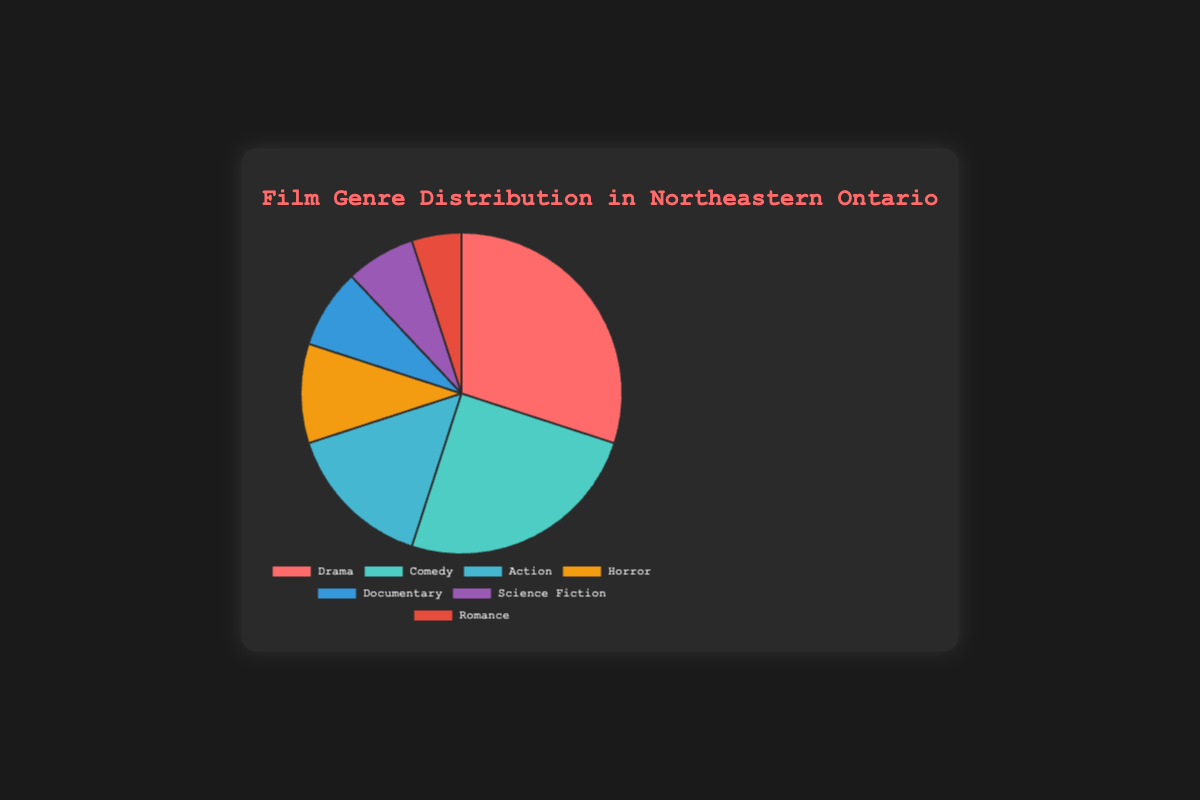What genre is the most watched by the audience in Northeastern Ontario? The pie chart shows that "Drama" occupies the largest section, with a percentage of 30%, making it the most watched genre.
Answer: Drama What is the least popular film genre among the audience in Northeastern Ontario? According to the pie chart, "Romance" has the smallest section with only 5% of the total, making it the least popular genre.
Answer: Romance How do the combined percentages of Action and Horror compare to the percentage of Drama? The percentages for Action and Horror are 15% and 10%, respectively. Adding them together gives 25%, which is less than Drama, which is 30%.
Answer: 25% < 30% What percentage of films watched are either Documentaries or Science Fiction? Documentaries account for 8% and Science Fiction for 7%. Adding these together results in 15%.
Answer: 15% What is the combined percentage for the top three film genres? The top three genres are Drama (30%), Comedy (25%), and Action (15%). Adding these together results in 70%.
Answer: 70% What is the ratio of Comedy films watched to Horror films watched? Comedy accounts for 25% while Horror accounts for 10%. The ratio of Comedy to Horror is 25% to 10%, which simplifies to 2.5:1.
Answer: 2.5:1 Which genres are represented by the colors red and green in the pie chart? Drama is represented by the color red and Comedy is represented by the color green.
Answer: Drama and Comedy Are there more audience members who watch Romance or Science Fiction films? According to the pie chart, 5% of the audience watches Romance, whereas 7% watches Science Fiction, indicating that more people watch Science Fiction films.
Answer: Science Fiction Which genres, when combined, make up more than half of the audience's preferences? Drama (30%), Comedy (25%), and Action (15%) together sum up to 70%, which is more than half of the total audience's preferences.
Answer: Drama, Comedy, and Action By how much does the percentage of Drama exceed the percentage of Horror? Drama has a percentage of 30% while Horror has 10%. The difference between them is 30% - 10% = 20%.
Answer: 20% 